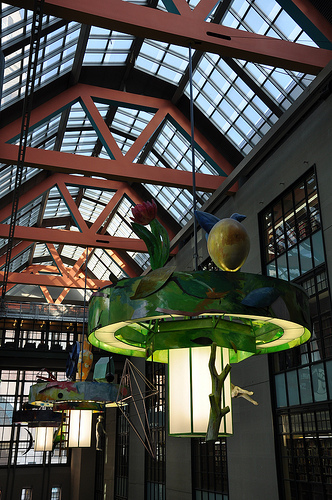<image>
Is the branch under the ceiling? Yes. The branch is positioned underneath the ceiling, with the ceiling above it in the vertical space. 